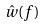Convert formula to latex. <formula><loc_0><loc_0><loc_500><loc_500>\hat { w } ( f )</formula> 